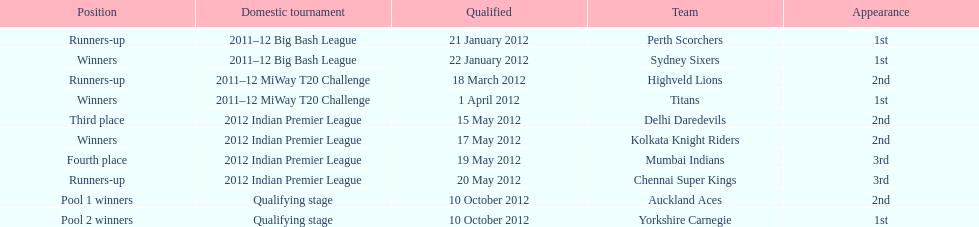Parse the table in full. {'header': ['Position', 'Domestic tournament', 'Qualified', 'Team', 'Appearance'], 'rows': [['Runners-up', '2011–12 Big Bash League', '21 January 2012', 'Perth Scorchers', '1st'], ['Winners', '2011–12 Big Bash League', '22 January 2012', 'Sydney Sixers', '1st'], ['Runners-up', '2011–12 MiWay T20 Challenge', '18 March 2012', 'Highveld Lions', '2nd'], ['Winners', '2011–12 MiWay T20 Challenge', '1 April 2012', 'Titans', '1st'], ['Third place', '2012 Indian Premier League', '15 May 2012', 'Delhi Daredevils', '2nd'], ['Winners', '2012 Indian Premier League', '17 May 2012', 'Kolkata Knight Riders', '2nd'], ['Fourth place', '2012 Indian Premier League', '19 May 2012', 'Mumbai Indians', '3rd'], ['Runners-up', '2012 Indian Premier League', '20 May 2012', 'Chennai Super Kings', '3rd'], ['Pool 1 winners', 'Qualifying stage', '10 October 2012', 'Auckland Aces', '2nd'], ['Pool 2 winners', 'Qualifying stage', '10 October 2012', 'Yorkshire Carnegie', '1st']]} What is the total number of teams that qualified? 10. 